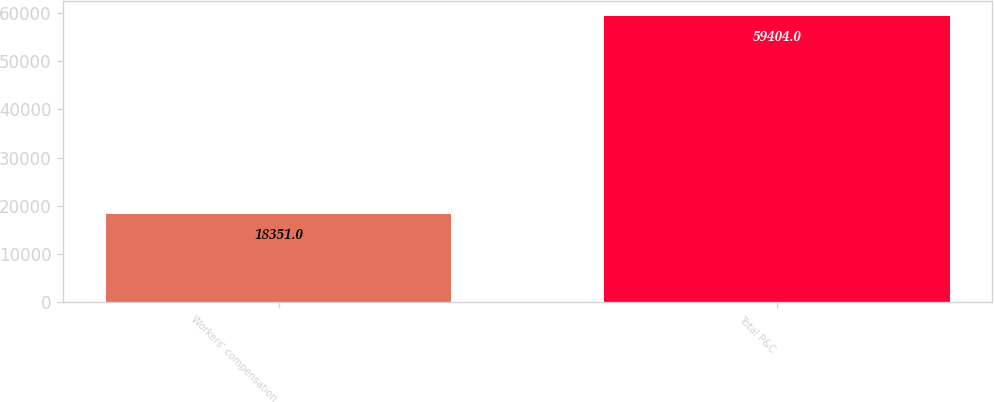Convert chart. <chart><loc_0><loc_0><loc_500><loc_500><bar_chart><fcel>Workers' compensation<fcel>Total P&C<nl><fcel>18351<fcel>59404<nl></chart> 